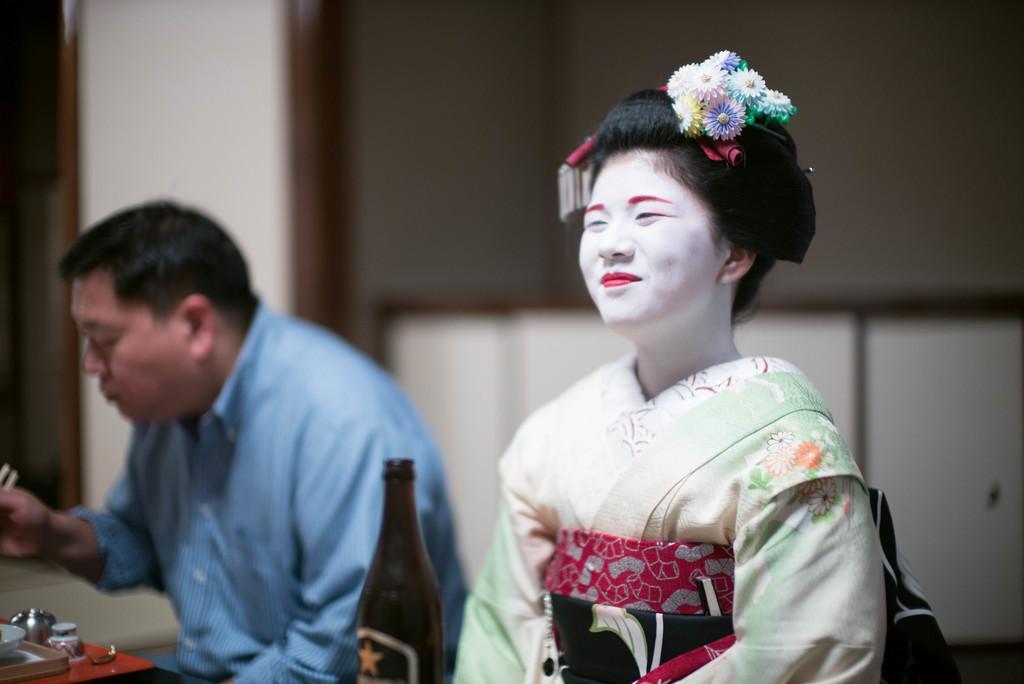Describe this image in one or two sentences. In this picture there is a woman sitting and smiling and there is a man sitting and holding the chopsticks. There are bowls on the table. In the foreground there is a bottle. At the back there is a wall. 